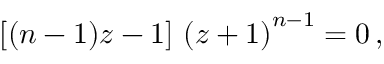Convert formula to latex. <formula><loc_0><loc_0><loc_500><loc_500>\left [ ( n - 1 ) z - 1 \right ] \, \left ( z + 1 \right ) ^ { n - 1 } = 0 \, ,</formula> 